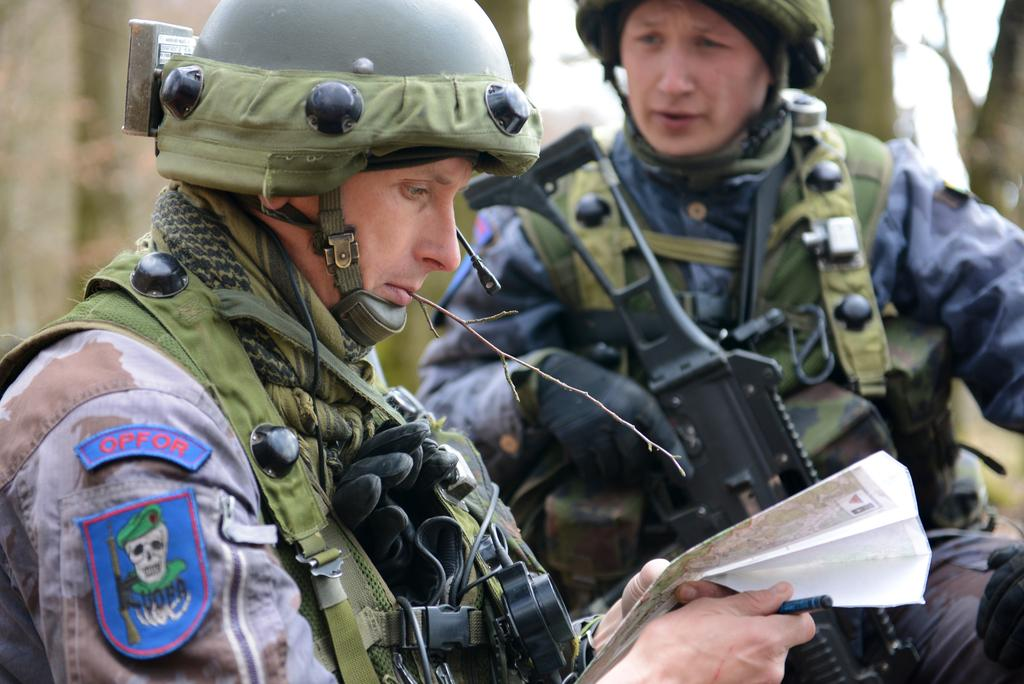What type of people can be seen in the image? There are soldiers in the image. Can you describe the person in the foreground? The person in the foreground is holding a map. What can be observed about the background of the image? The background of the image is blurred. How many cents are visible on the sheep in the image? There are no sheep or cents present in the image. What type of fiction is being read by the soldiers in the image? There is no indication of any fiction being read by the soldiers in the image. 